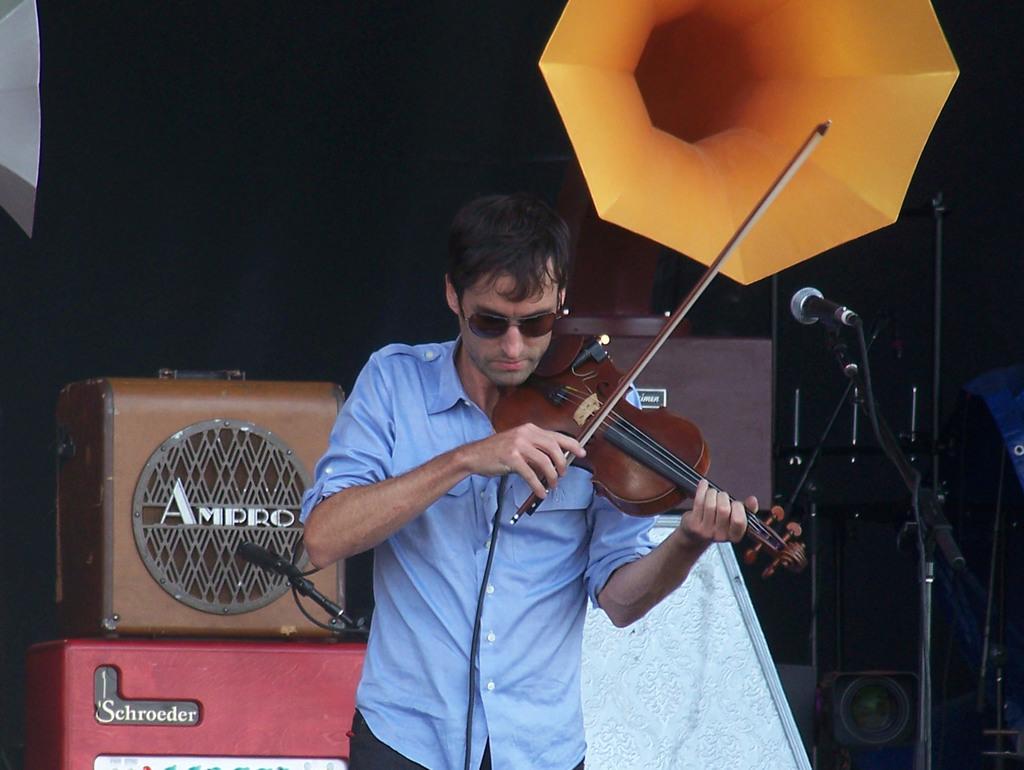Could you give a brief overview of what you see in this image? In this image i can see a person wearing blue shirt and glasses, holding a violin in his hands. In the background i can see some boxes and a speaker. I can see microphone in front of him. 